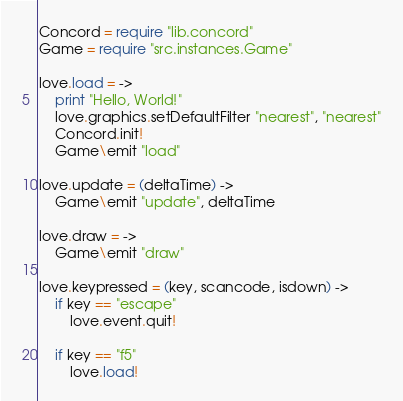Convert code to text. <code><loc_0><loc_0><loc_500><loc_500><_MoonScript_>Concord = require "lib.concord"
Game = require "src.instances.Game"

love.load = ->
	print "Hello, World!"
	love.graphics.setDefaultFilter "nearest", "nearest"
	Concord.init!
	Game\emit "load"

love.update = (deltaTime) ->
	Game\emit "update", deltaTime

love.draw = ->
	Game\emit "draw"

love.keypressed = (key, scancode, isdown) ->
	if key == "escape"
		love.event.quit!

	if key == "f5"
		love.load!</code> 